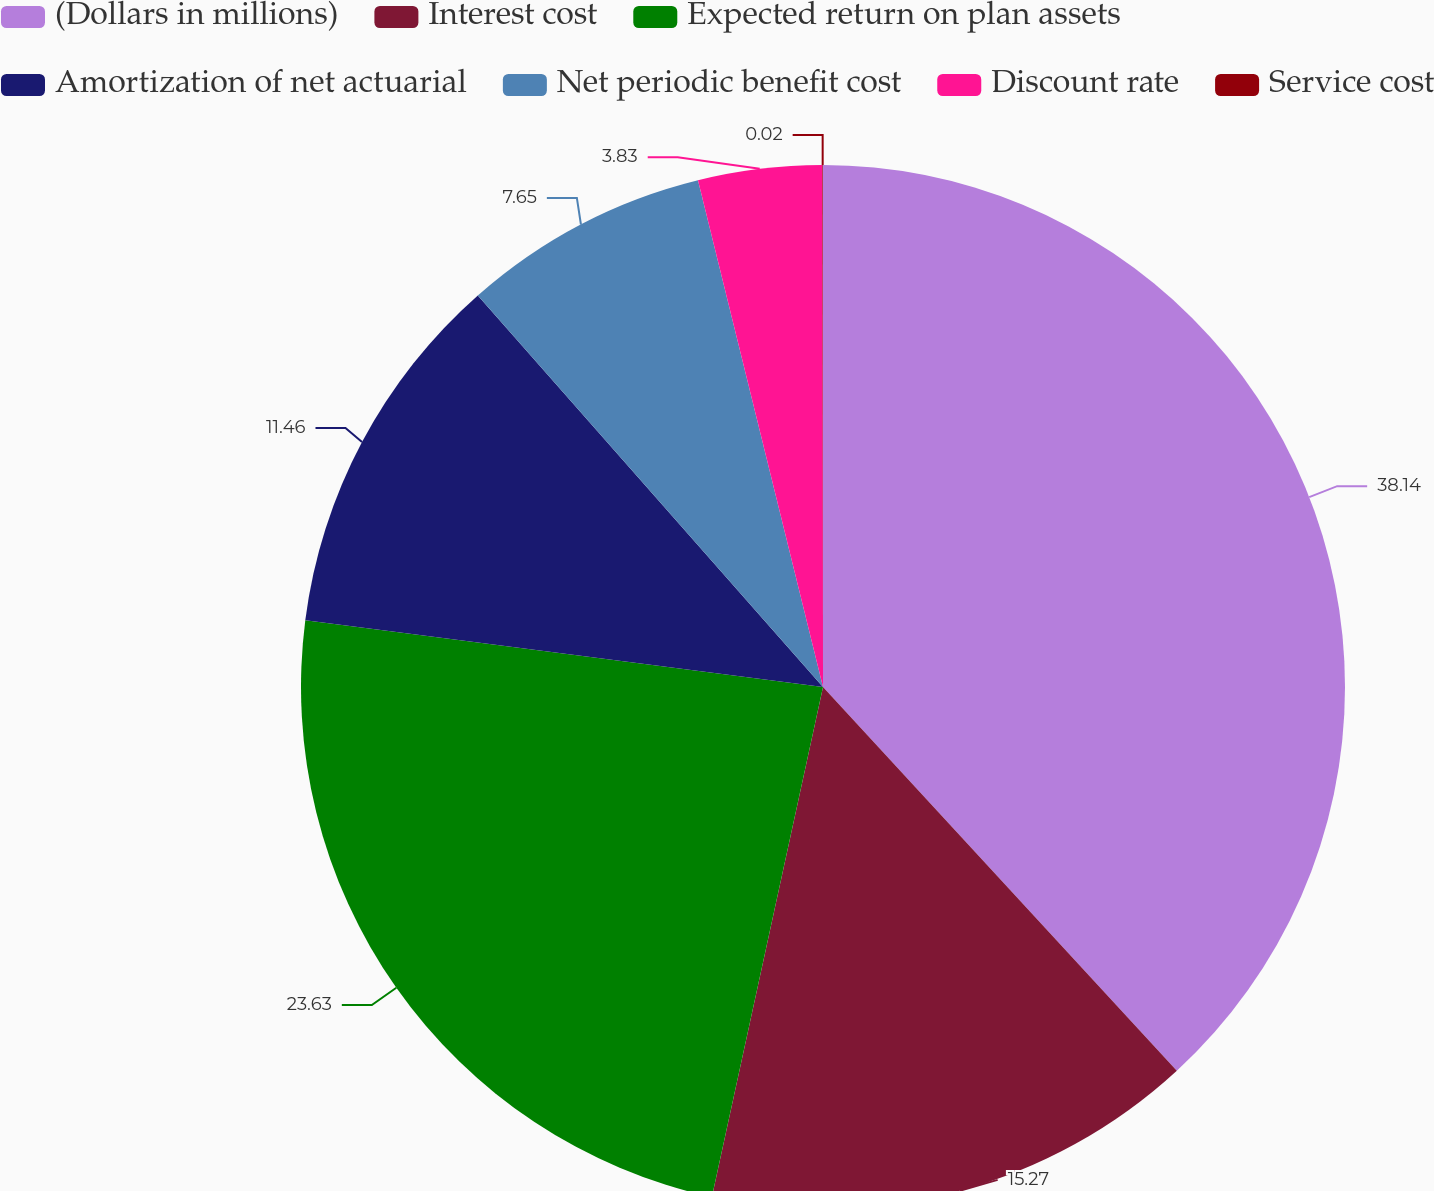Convert chart. <chart><loc_0><loc_0><loc_500><loc_500><pie_chart><fcel>(Dollars in millions)<fcel>Interest cost<fcel>Expected return on plan assets<fcel>Amortization of net actuarial<fcel>Net periodic benefit cost<fcel>Discount rate<fcel>Service cost<nl><fcel>38.15%<fcel>15.27%<fcel>23.63%<fcel>11.46%<fcel>7.65%<fcel>3.83%<fcel>0.02%<nl></chart> 